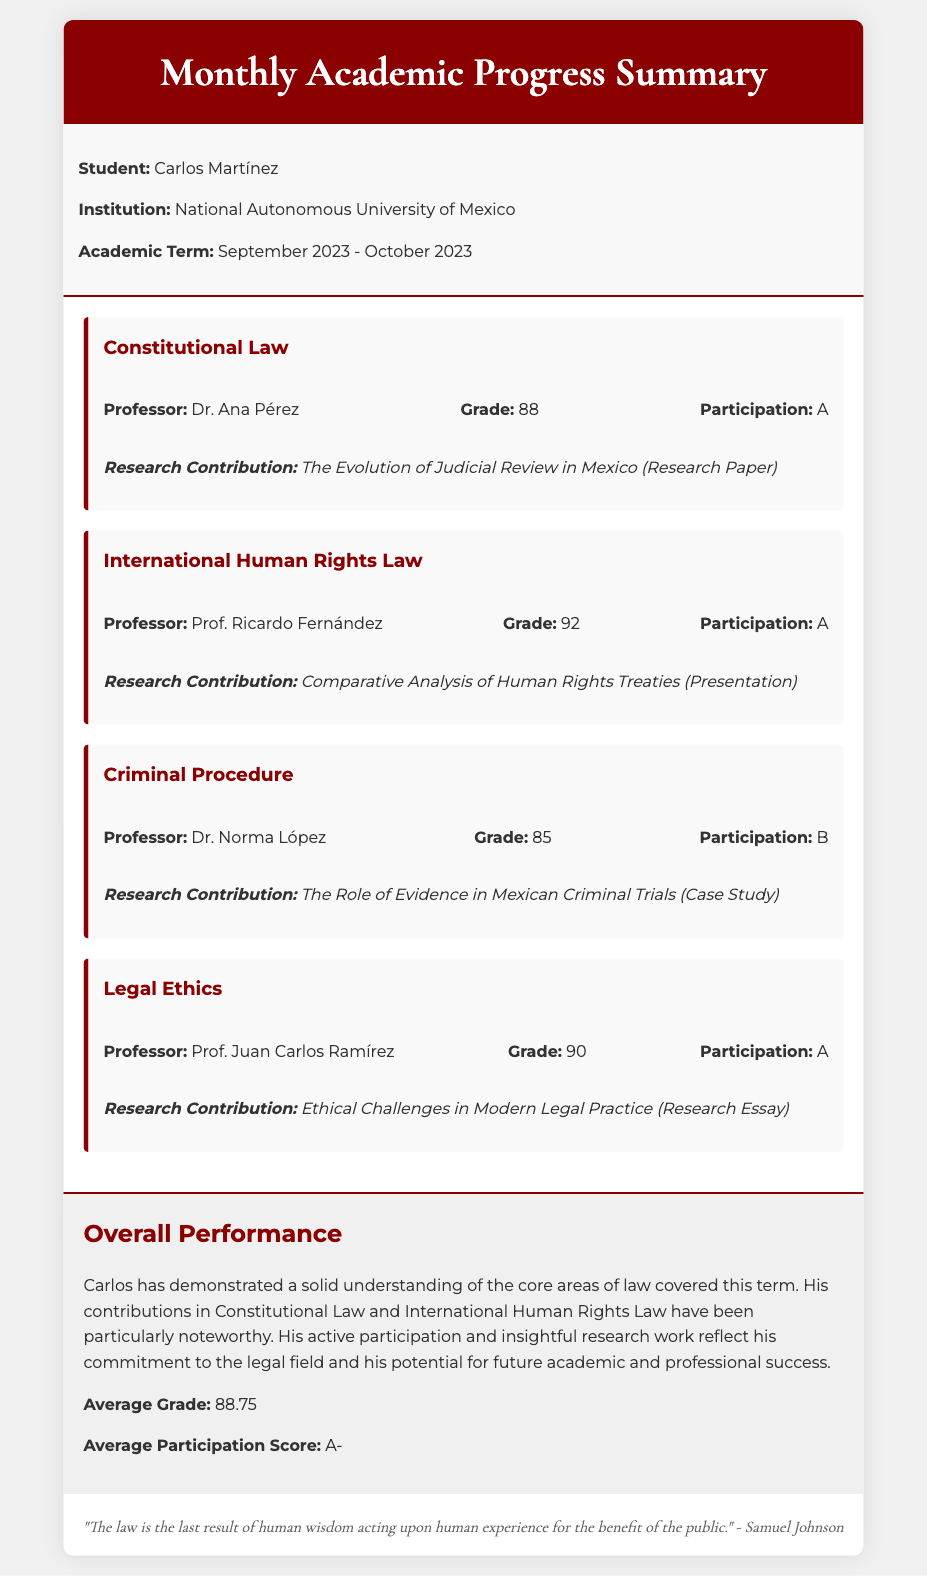What is the student's name? The student's name is given in the document, which states "Carlos Martínez."
Answer: Carlos Martínez What is the institution's name? The institution is specified in the document as "National Autonomous University of Mexico."
Answer: National Autonomous University of Mexico Who is the professor for International Human Rights Law? The document lists the professor for this course as "Prof. Ricardo Fernández."
Answer: Prof. Ricardo Fernández What was the grade in Criminal Procedure? The grade is noted in the document and is listed as "85."
Answer: 85 What is the participation score for Legal Ethics? The participation score is mentioned in the document as "A."
Answer: A What is the research contribution for Constitutional Law? The specific research contribution is provided in the document as "The Evolution of Judicial Review in Mexico (Research Paper)."
Answer: The Evolution of Judicial Review in Mexico (Research Paper) What is Carlos's average grade? The average grade is stated in the overall performance section of the document as "88.75."
Answer: 88.75 What has Carlos demonstrated in the core areas of law this term? The document states that Carlos has a "solid understanding."
Answer: solid understanding How is Carlos's participation described in the overall performance section? It is described in the document as "active participation and insightful research work."
Answer: active participation and insightful research work What is the quote at the bottom of the document? The quote provided in the document is from Samuel Johnson, stating, "The law is the last result of human wisdom acting upon human experience for the benefit of the public."
Answer: "The law is the last result of human wisdom acting upon human experience for the benefit of the public." 